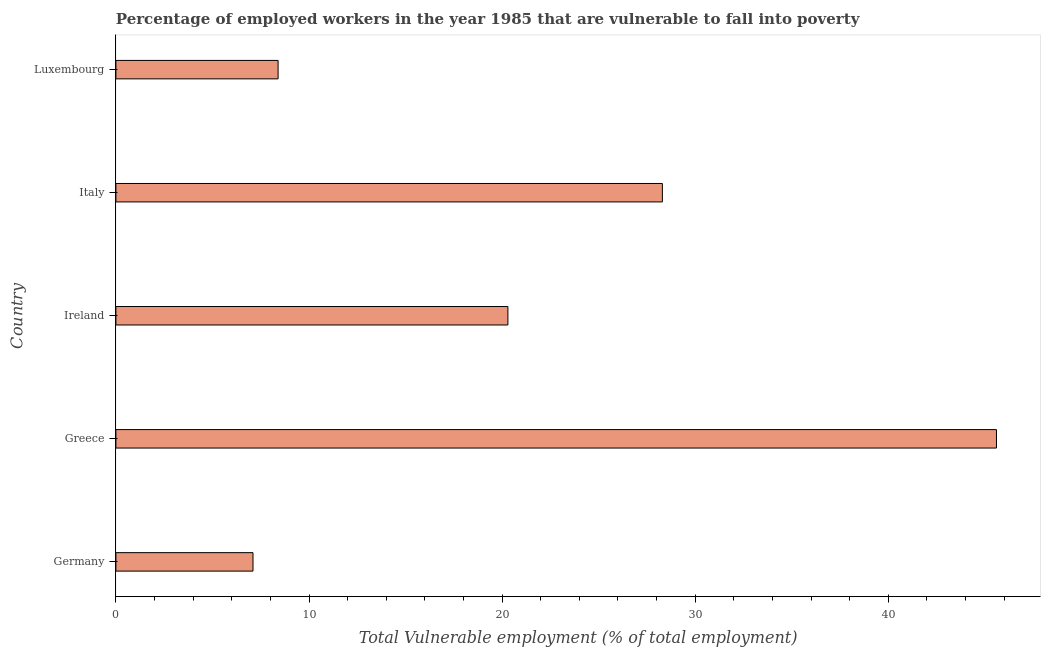What is the title of the graph?
Your answer should be very brief. Percentage of employed workers in the year 1985 that are vulnerable to fall into poverty. What is the label or title of the X-axis?
Your answer should be very brief. Total Vulnerable employment (% of total employment). What is the label or title of the Y-axis?
Make the answer very short. Country. What is the total vulnerable employment in Greece?
Ensure brevity in your answer.  45.6. Across all countries, what is the maximum total vulnerable employment?
Offer a very short reply. 45.6. Across all countries, what is the minimum total vulnerable employment?
Provide a succinct answer. 7.1. In which country was the total vulnerable employment minimum?
Ensure brevity in your answer.  Germany. What is the sum of the total vulnerable employment?
Provide a short and direct response. 109.7. What is the average total vulnerable employment per country?
Your response must be concise. 21.94. What is the median total vulnerable employment?
Provide a short and direct response. 20.3. In how many countries, is the total vulnerable employment greater than 38 %?
Ensure brevity in your answer.  1. What is the ratio of the total vulnerable employment in Germany to that in Luxembourg?
Make the answer very short. 0.84. Is the total vulnerable employment in Germany less than that in Greece?
Make the answer very short. Yes. What is the difference between the highest and the lowest total vulnerable employment?
Give a very brief answer. 38.5. In how many countries, is the total vulnerable employment greater than the average total vulnerable employment taken over all countries?
Your answer should be compact. 2. Are all the bars in the graph horizontal?
Your answer should be compact. Yes. How many countries are there in the graph?
Offer a very short reply. 5. What is the difference between two consecutive major ticks on the X-axis?
Your answer should be very brief. 10. Are the values on the major ticks of X-axis written in scientific E-notation?
Offer a very short reply. No. What is the Total Vulnerable employment (% of total employment) of Germany?
Your answer should be very brief. 7.1. What is the Total Vulnerable employment (% of total employment) of Greece?
Your response must be concise. 45.6. What is the Total Vulnerable employment (% of total employment) of Ireland?
Give a very brief answer. 20.3. What is the Total Vulnerable employment (% of total employment) of Italy?
Make the answer very short. 28.3. What is the Total Vulnerable employment (% of total employment) in Luxembourg?
Provide a short and direct response. 8.4. What is the difference between the Total Vulnerable employment (% of total employment) in Germany and Greece?
Your answer should be very brief. -38.5. What is the difference between the Total Vulnerable employment (% of total employment) in Germany and Italy?
Make the answer very short. -21.2. What is the difference between the Total Vulnerable employment (% of total employment) in Greece and Ireland?
Offer a terse response. 25.3. What is the difference between the Total Vulnerable employment (% of total employment) in Greece and Italy?
Give a very brief answer. 17.3. What is the difference between the Total Vulnerable employment (% of total employment) in Greece and Luxembourg?
Your response must be concise. 37.2. What is the difference between the Total Vulnerable employment (% of total employment) in Ireland and Italy?
Give a very brief answer. -8. What is the difference between the Total Vulnerable employment (% of total employment) in Ireland and Luxembourg?
Give a very brief answer. 11.9. What is the difference between the Total Vulnerable employment (% of total employment) in Italy and Luxembourg?
Offer a terse response. 19.9. What is the ratio of the Total Vulnerable employment (% of total employment) in Germany to that in Greece?
Provide a short and direct response. 0.16. What is the ratio of the Total Vulnerable employment (% of total employment) in Germany to that in Ireland?
Keep it short and to the point. 0.35. What is the ratio of the Total Vulnerable employment (% of total employment) in Germany to that in Italy?
Give a very brief answer. 0.25. What is the ratio of the Total Vulnerable employment (% of total employment) in Germany to that in Luxembourg?
Provide a short and direct response. 0.84. What is the ratio of the Total Vulnerable employment (% of total employment) in Greece to that in Ireland?
Provide a succinct answer. 2.25. What is the ratio of the Total Vulnerable employment (% of total employment) in Greece to that in Italy?
Your response must be concise. 1.61. What is the ratio of the Total Vulnerable employment (% of total employment) in Greece to that in Luxembourg?
Keep it short and to the point. 5.43. What is the ratio of the Total Vulnerable employment (% of total employment) in Ireland to that in Italy?
Make the answer very short. 0.72. What is the ratio of the Total Vulnerable employment (% of total employment) in Ireland to that in Luxembourg?
Your response must be concise. 2.42. What is the ratio of the Total Vulnerable employment (% of total employment) in Italy to that in Luxembourg?
Offer a very short reply. 3.37. 